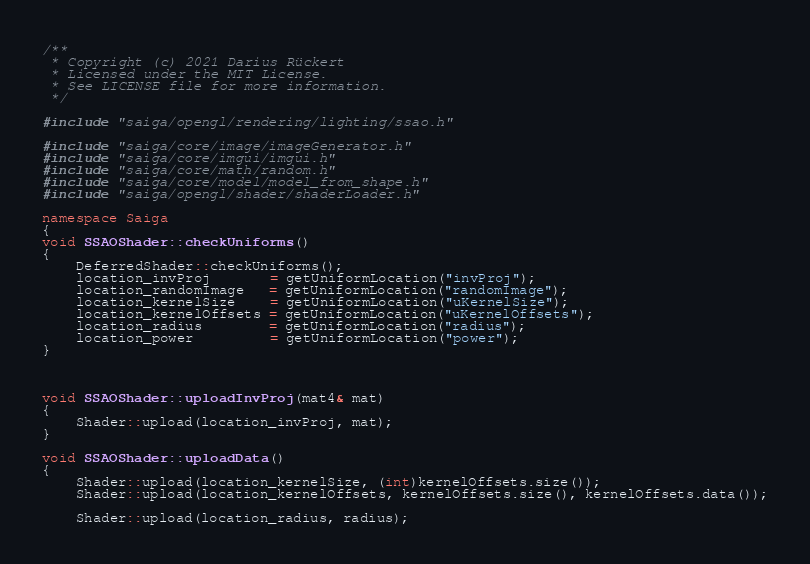<code> <loc_0><loc_0><loc_500><loc_500><_C++_>/**
 * Copyright (c) 2021 Darius Rückert
 * Licensed under the MIT License.
 * See LICENSE file for more information.
 */

#include "saiga/opengl/rendering/lighting/ssao.h"

#include "saiga/core/image/imageGenerator.h"
#include "saiga/core/imgui/imgui.h"
#include "saiga/core/math/random.h"
#include "saiga/core/model/model_from_shape.h"
#include "saiga/opengl/shader/shaderLoader.h"

namespace Saiga
{
void SSAOShader::checkUniforms()
{
    DeferredShader::checkUniforms();
    location_invProj       = getUniformLocation("invProj");
    location_randomImage   = getUniformLocation("randomImage");
    location_kernelSize    = getUniformLocation("uKernelSize");
    location_kernelOffsets = getUniformLocation("uKernelOffsets");
    location_radius        = getUniformLocation("radius");
    location_power         = getUniformLocation("power");
}



void SSAOShader::uploadInvProj(mat4& mat)
{
    Shader::upload(location_invProj, mat);
}

void SSAOShader::uploadData()
{
    Shader::upload(location_kernelSize, (int)kernelOffsets.size());
    Shader::upload(location_kernelOffsets, kernelOffsets.size(), kernelOffsets.data());

    Shader::upload(location_radius, radius);</code> 